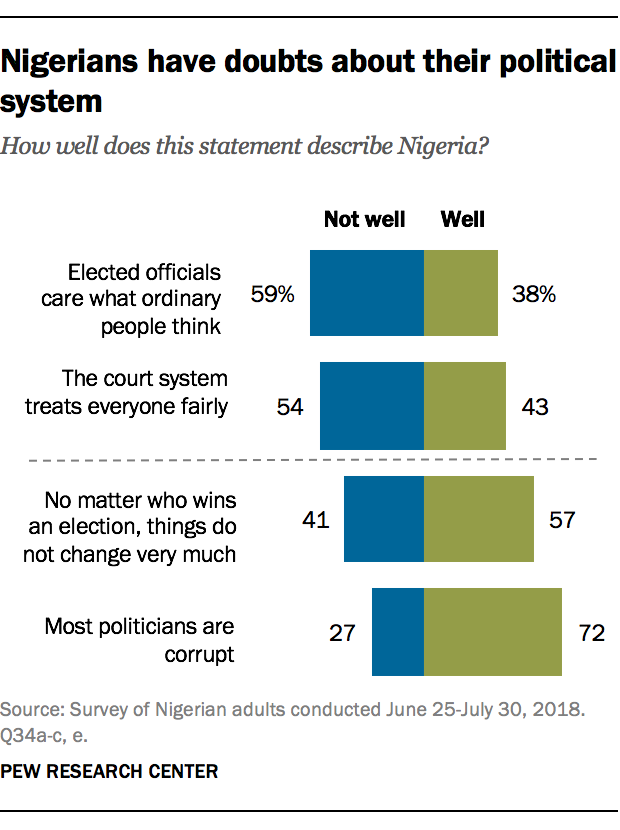List a handful of essential elements in this visual. There are four values in the well that are below 50. 